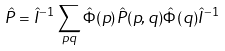<formula> <loc_0><loc_0><loc_500><loc_500>\hat { P } = \hat { I } ^ { - 1 } \sum _ { p q } \hat { \Phi } ( p ) \hat { P } ( p , q ) \hat { \Phi } ( q ) \hat { I } ^ { - 1 }</formula> 